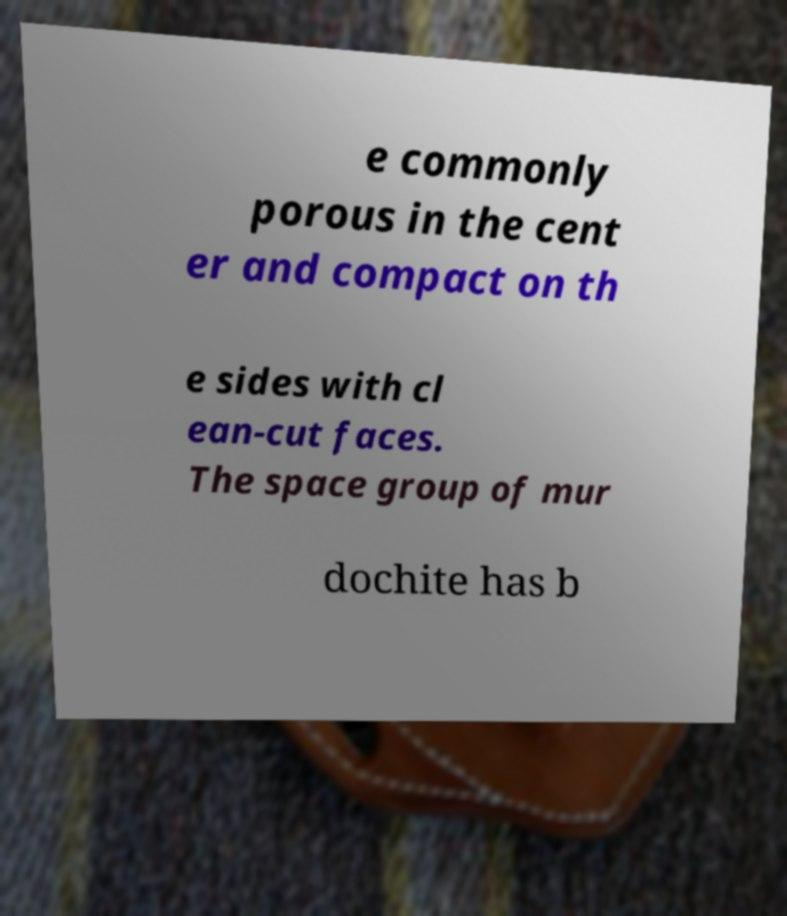Please identify and transcribe the text found in this image. e commonly porous in the cent er and compact on th e sides with cl ean-cut faces. The space group of mur dochite has b 